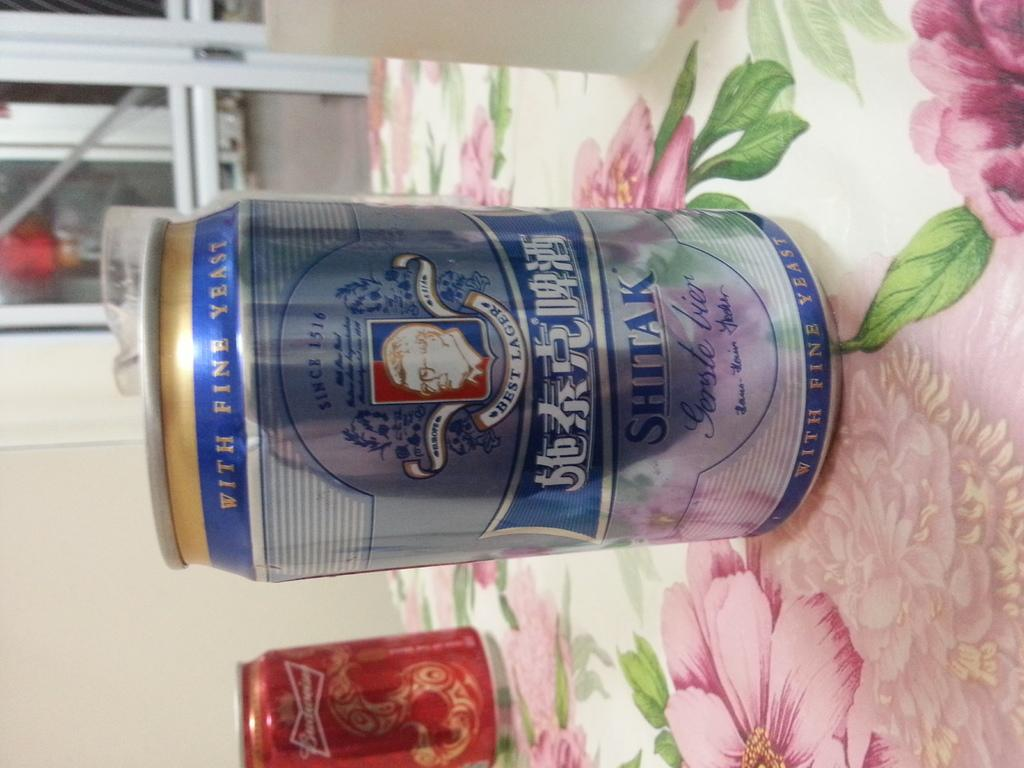<image>
Write a terse but informative summary of the picture. A can of beer that has the words best lager on it 